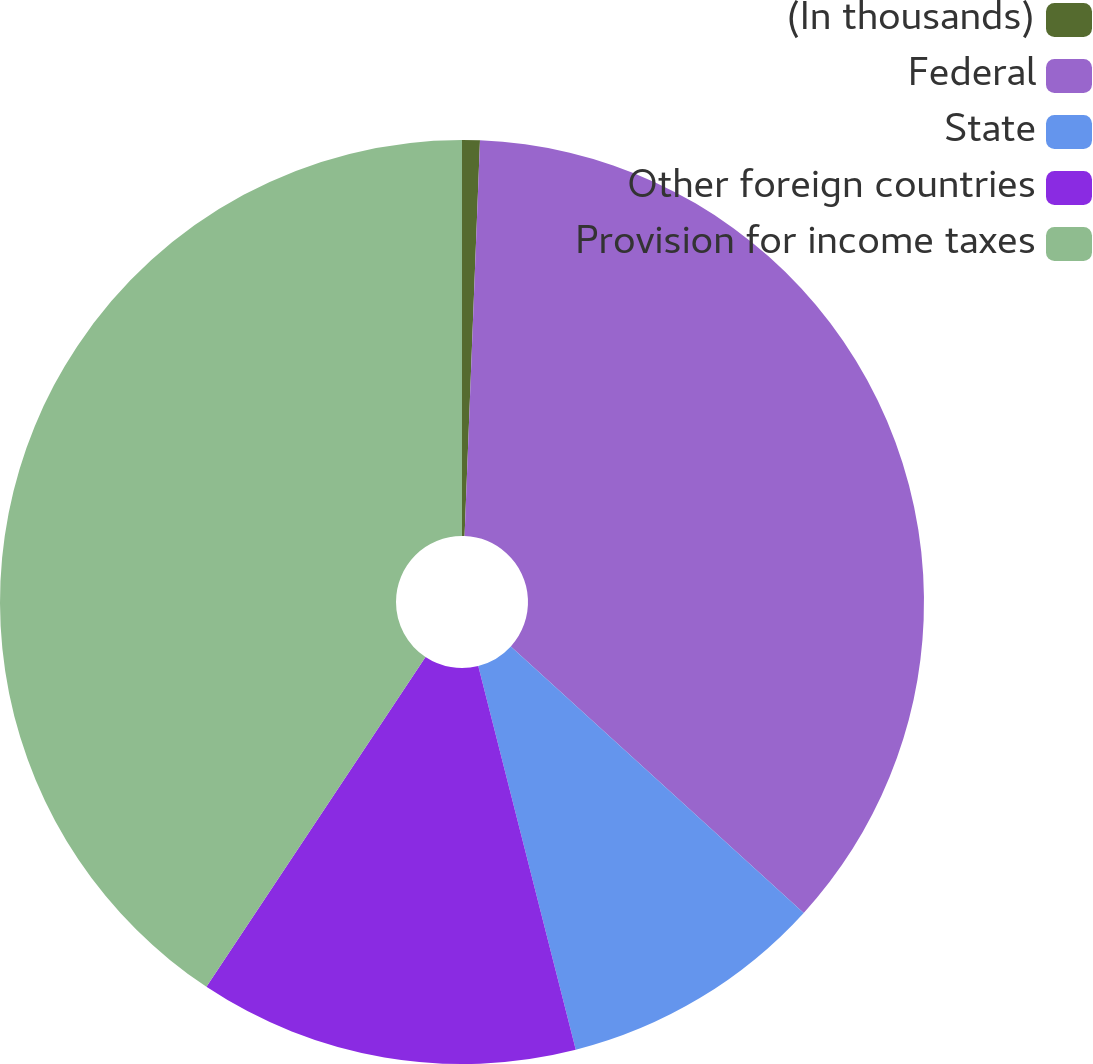<chart> <loc_0><loc_0><loc_500><loc_500><pie_chart><fcel>(In thousands)<fcel>Federal<fcel>State<fcel>Other foreign countries<fcel>Provision for income taxes<nl><fcel>0.62%<fcel>36.13%<fcel>9.29%<fcel>13.29%<fcel>40.67%<nl></chart> 